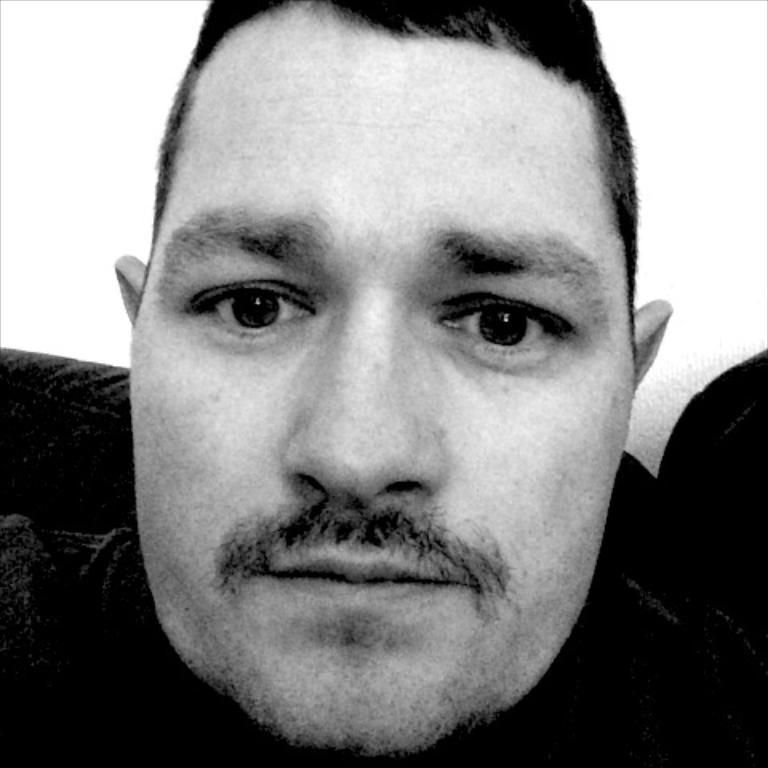Could you give a brief overview of what you see in this image? In this picture we can see a person's face and in the background we can see an object. 